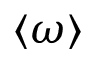<formula> <loc_0><loc_0><loc_500><loc_500>\langle \omega \rangle</formula> 